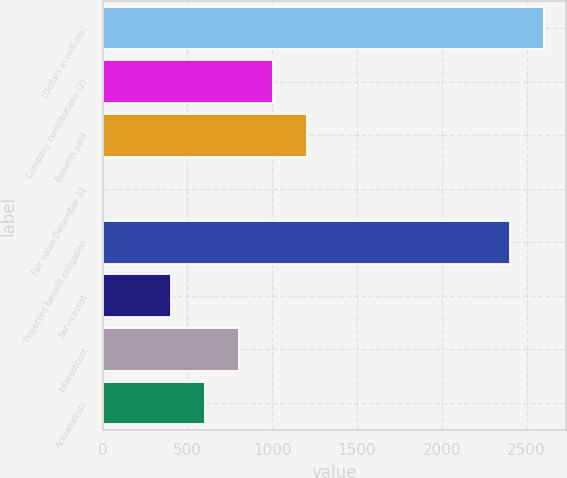Convert chart. <chart><loc_0><loc_0><loc_500><loc_500><bar_chart><fcel>(Dollars in millions)<fcel>Company contributions (2)<fcel>Benefits paid<fcel>Fair value December 31<fcel>Projected benefit obligation<fcel>Servicecost<fcel>Interestcost<fcel>Actuarialloss<nl><fcel>2604.9<fcel>1002.5<fcel>1202.8<fcel>1<fcel>2404.6<fcel>401.6<fcel>802.2<fcel>601.9<nl></chart> 